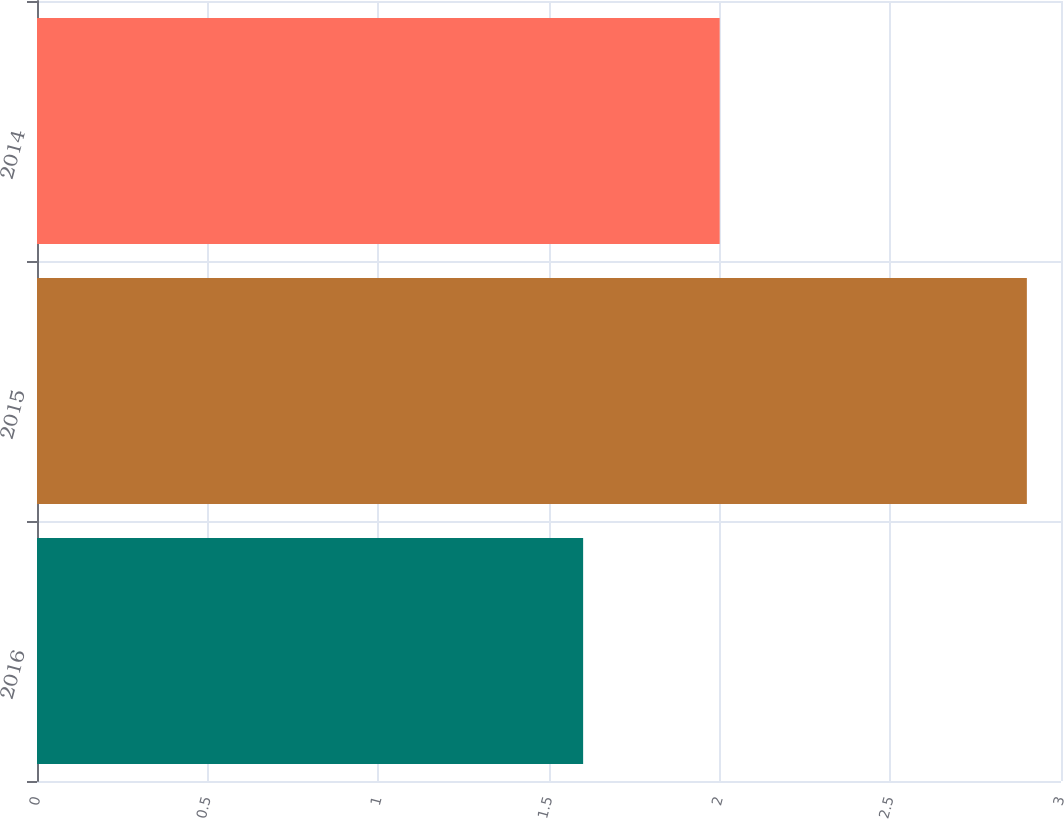<chart> <loc_0><loc_0><loc_500><loc_500><bar_chart><fcel>2016<fcel>2015<fcel>2014<nl><fcel>1.6<fcel>2.9<fcel>2<nl></chart> 